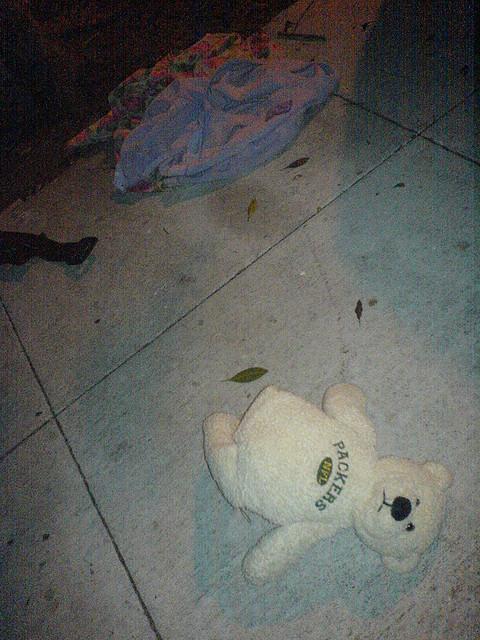How many green cars are there?
Give a very brief answer. 0. 